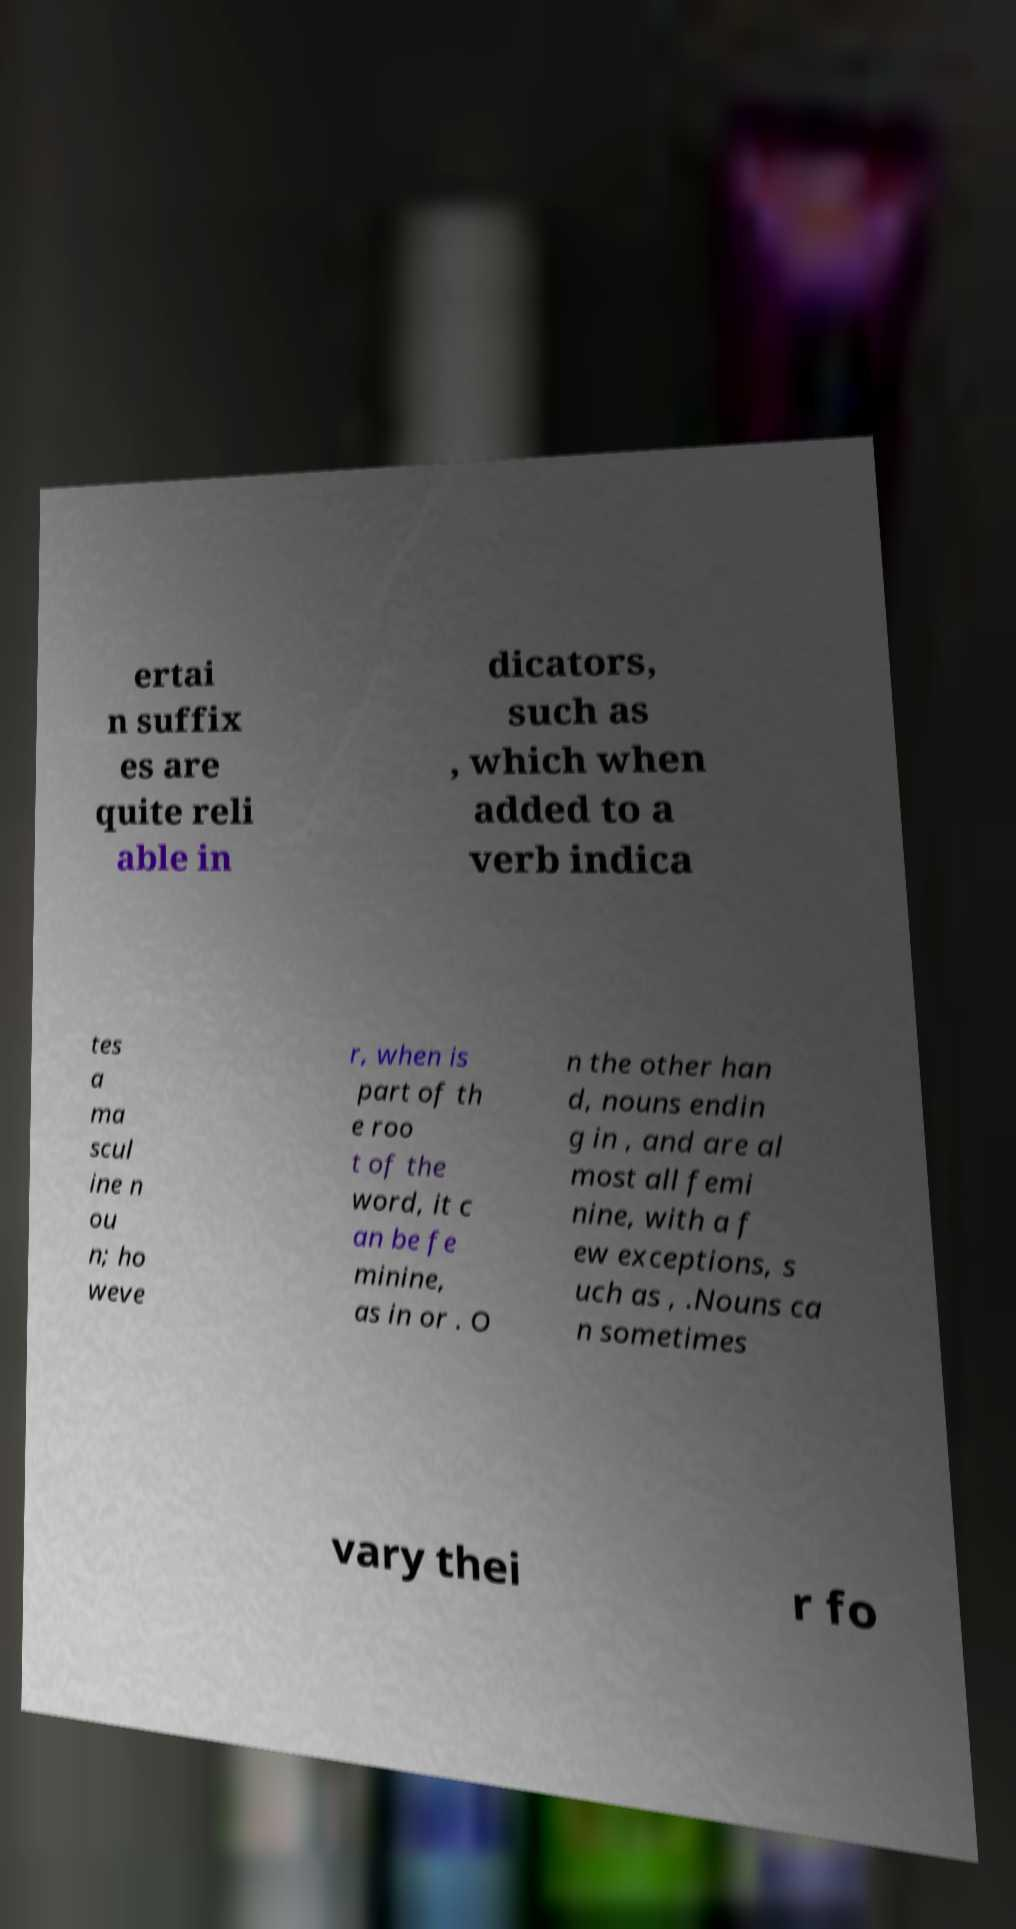For documentation purposes, I need the text within this image transcribed. Could you provide that? ertai n suffix es are quite reli able in dicators, such as , which when added to a verb indica tes a ma scul ine n ou n; ho weve r, when is part of th e roo t of the word, it c an be fe minine, as in or . O n the other han d, nouns endin g in , and are al most all femi nine, with a f ew exceptions, s uch as , .Nouns ca n sometimes vary thei r fo 